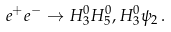Convert formula to latex. <formula><loc_0><loc_0><loc_500><loc_500>e ^ { + } e ^ { - } \to H ^ { 0 } _ { 3 } H ^ { 0 } _ { 5 } , H ^ { 0 } _ { 3 } \psi _ { 2 } \, .</formula> 